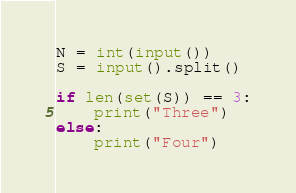Convert code to text. <code><loc_0><loc_0><loc_500><loc_500><_Python_>N = int(input())
S = input().split()

if len(set(S)) == 3:
    print("Three")
else:
    print("Four")</code> 